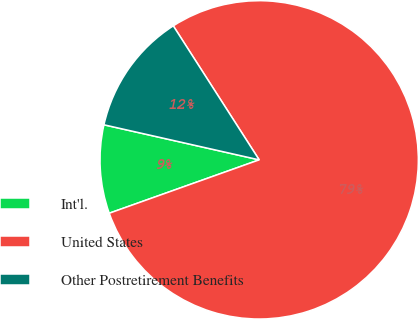Convert chart. <chart><loc_0><loc_0><loc_500><loc_500><pie_chart><fcel>Int'l.<fcel>United States<fcel>Other Postretirement Benefits<nl><fcel>8.98%<fcel>78.63%<fcel>12.39%<nl></chart> 